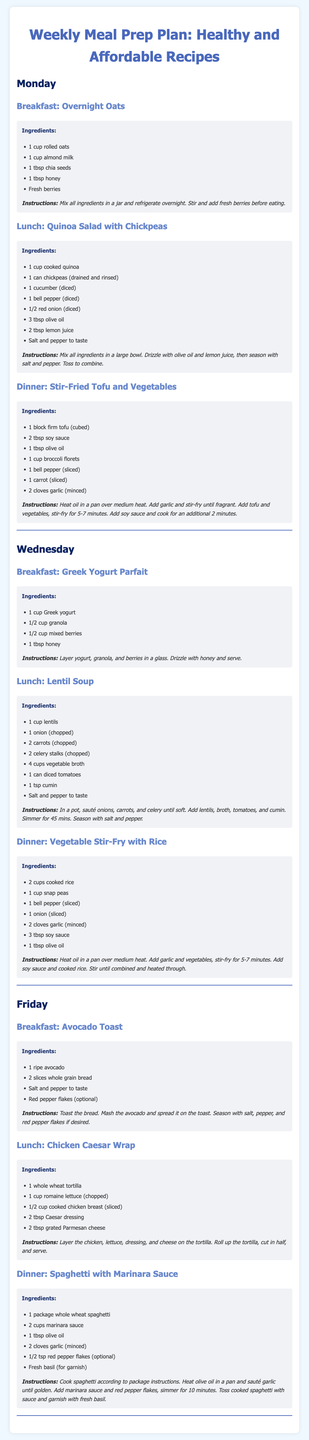What is the title of the document? The title of the document is found in the <title> tag in the header section, which is "Weekly Meal Prep Plan".
Answer: Weekly Meal Prep Plan How many meals are listed for Monday? The meals for Monday include breakfast, lunch, and dinner, totaling three meals.
Answer: 3 What is the first ingredient of the Overnight Oats? The first ingredient listed in the Overnight Oats recipe is "1 cup rolled oats".
Answer: 1 cup rolled oats What is the main protein source in the Lunch on Monday? The Lunch option on Monday is a Quinoa Salad with Chickpeas, making chickpeas the main protein source.
Answer: Chickpeas Which day features a Vegetable Stir-Fry for dinner? The document includes a Vegetable Stir-Fry with Rice for dinner, and it is served on Wednesday.
Answer: Wednesday How is the green pepper described in the dinner of Monday? The dinner includes "1 bell pepper (sliced)", which describes the green pepper.
Answer: 1 bell pepper (sliced) What type of bread is used in the Avocado Toast? The Avocado Toast is made using "2 slices whole grain bread".
Answer: whole grain bread Which recipe includes yogurt as an ingredient? The recipe that includes yogurt is "Greek Yogurt Parfait" for breakfast on Wednesday.
Answer: Greek Yogurt Parfait 